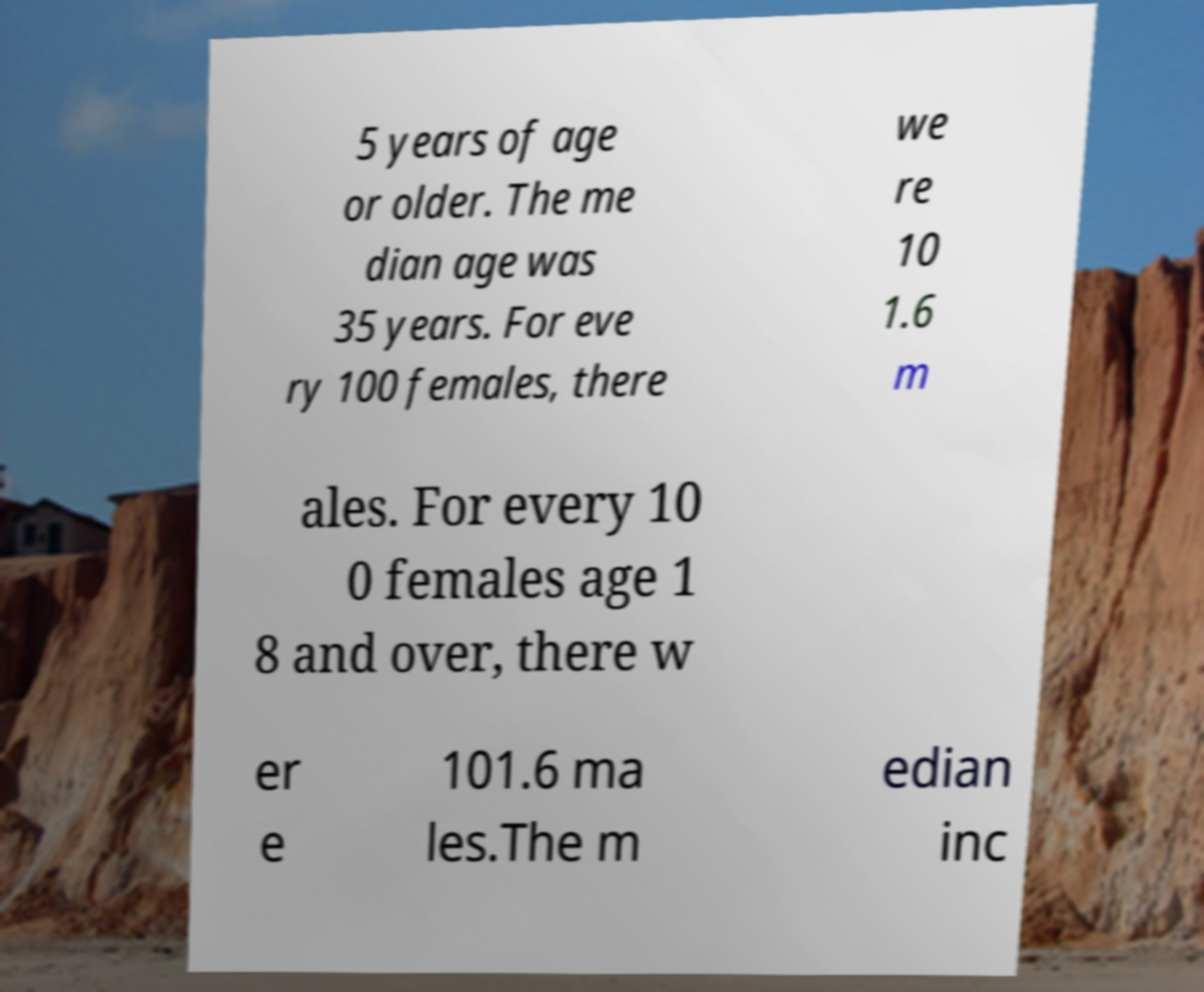Please identify and transcribe the text found in this image. 5 years of age or older. The me dian age was 35 years. For eve ry 100 females, there we re 10 1.6 m ales. For every 10 0 females age 1 8 and over, there w er e 101.6 ma les.The m edian inc 